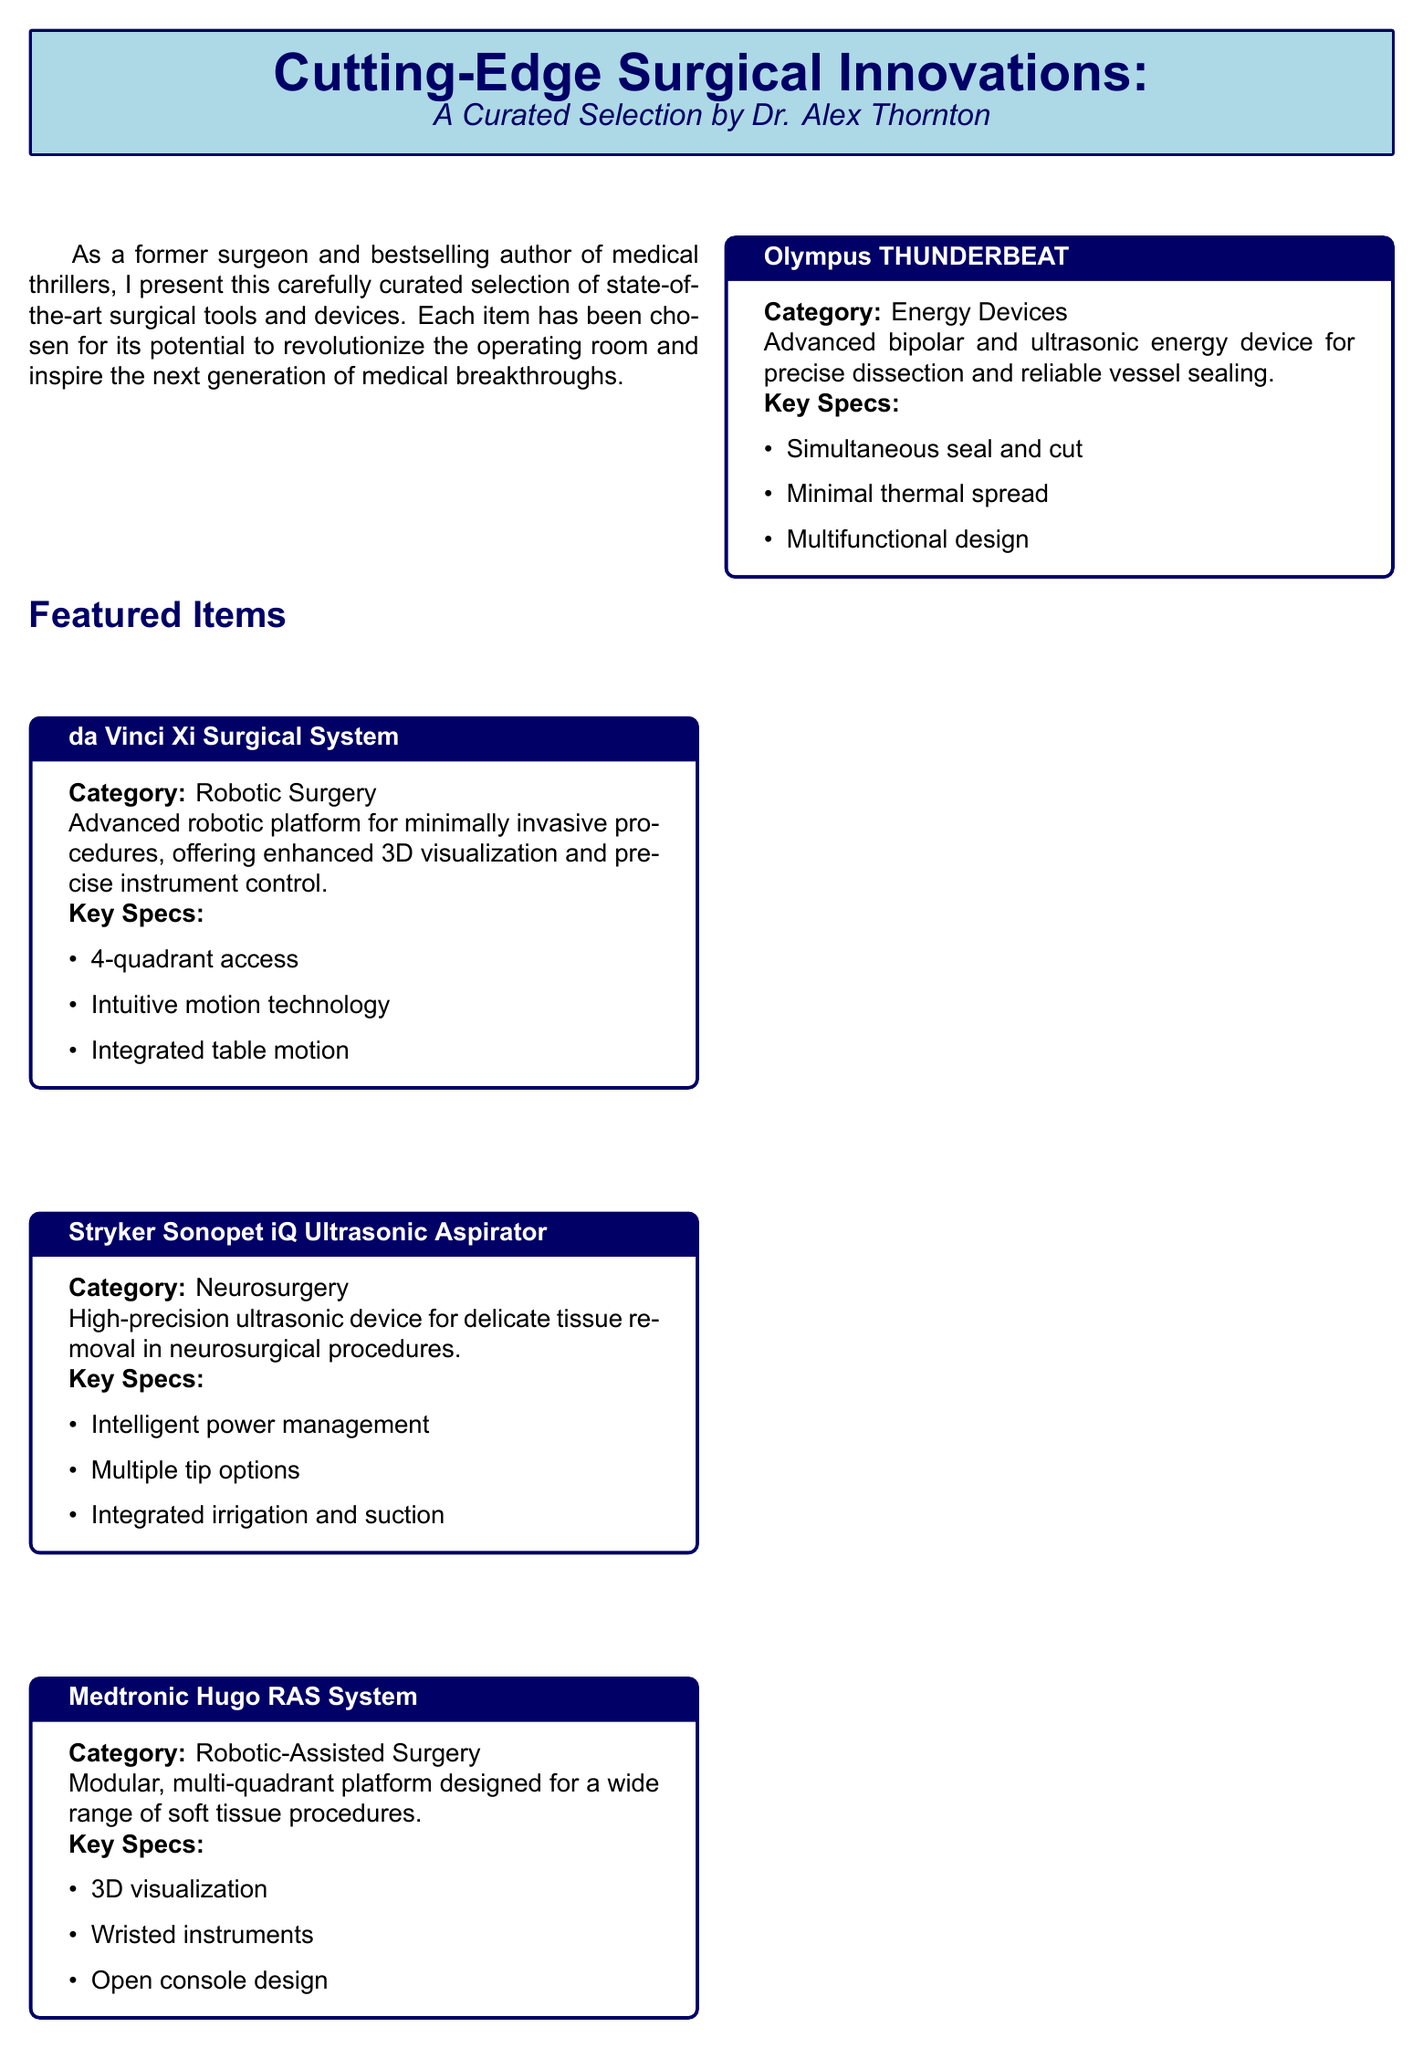what is the name of the robotic surgical system featured? The document identifies the robotic surgical system as the da Vinci Xi Surgical System.
Answer: da Vinci Xi Surgical System how many tip options does the Stryker Sonopet iQ Ultrasonic Aspirator have? The Stryker Sonopet iQ Ultrasonic Aspirator has multiple tip options listed in its specifications.
Answer: Multiple tip options what is the category of the Medtronic Hugo RAS System? The Medtronic Hugo RAS System is categorized under Robotic-Assisted Surgery.
Answer: Robotic-Assisted Surgery what is a key feature of the Olympus THUNDERBEAT? A key feature of the Olympus THUNDERBEAT is its ability for simultaneous seal and cut.
Answer: Simultaneous seal and cut which company manufactures the Stryker Sonopet iQ Ultrasonic Aspirator? The document states that the Stryker Sonopet iQ Ultrasonic Aspirator is manufactured by Stryker.
Answer: Stryker what type of device is the Olympus THUNDERBEAT? The Olympus THUNDERBEAT is categorized as an energy device.
Answer: Energy Devices which surgeon is curating this catalog? The catalog is curated by Dr. Alex Thornton.
Answer: Dr. Alex Thornton what is the purpose of including these surgical innovations in the catalog? The purpose is to enhance surgical precision and inspire the next generation of medical breakthroughs.
Answer: Enhance surgical precision and inspire breakthroughs how is the Medtronic Hugo RAS System designed? The Medtronic Hugo RAS System is designed as a modular, multi-quadrant platform.
Answer: Modular, multi-quadrant platform 